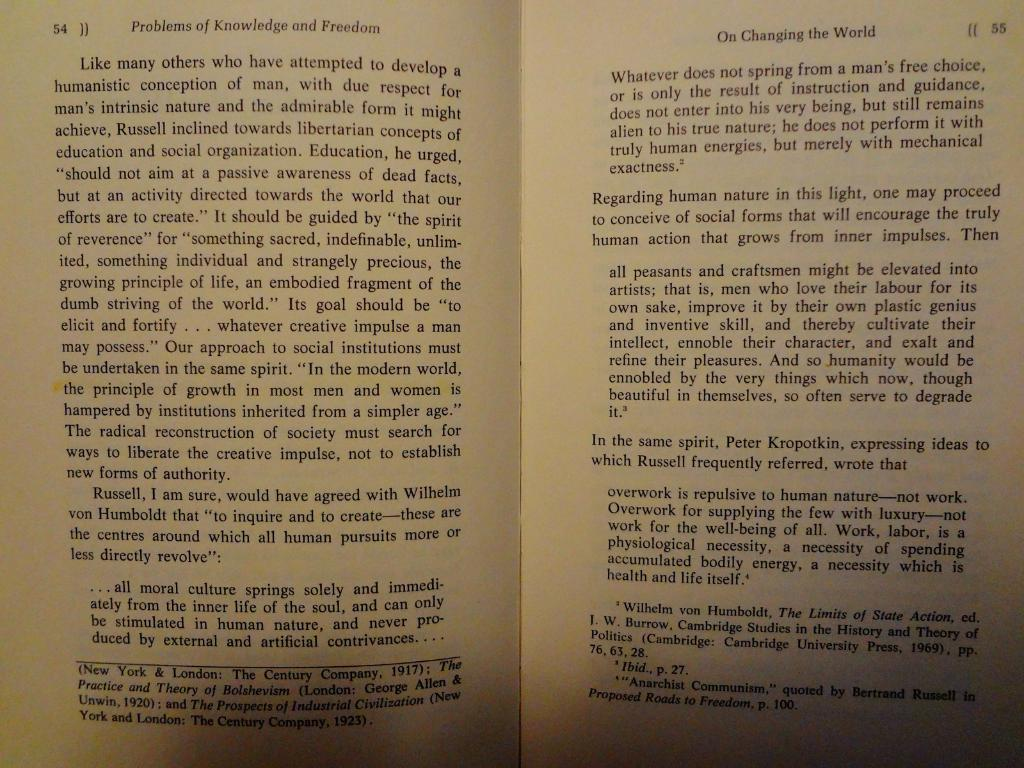<image>
Present a compact description of the photo's key features. Pages 54 and 55 of a book on Problems of Knowledge and Freedom and the Changing of the World. 